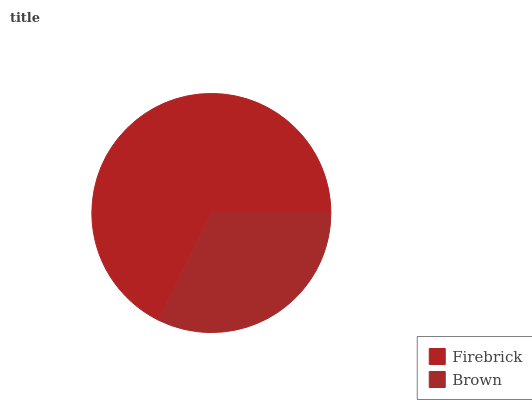Is Brown the minimum?
Answer yes or no. Yes. Is Firebrick the maximum?
Answer yes or no. Yes. Is Brown the maximum?
Answer yes or no. No. Is Firebrick greater than Brown?
Answer yes or no. Yes. Is Brown less than Firebrick?
Answer yes or no. Yes. Is Brown greater than Firebrick?
Answer yes or no. No. Is Firebrick less than Brown?
Answer yes or no. No. Is Firebrick the high median?
Answer yes or no. Yes. Is Brown the low median?
Answer yes or no. Yes. Is Brown the high median?
Answer yes or no. No. Is Firebrick the low median?
Answer yes or no. No. 